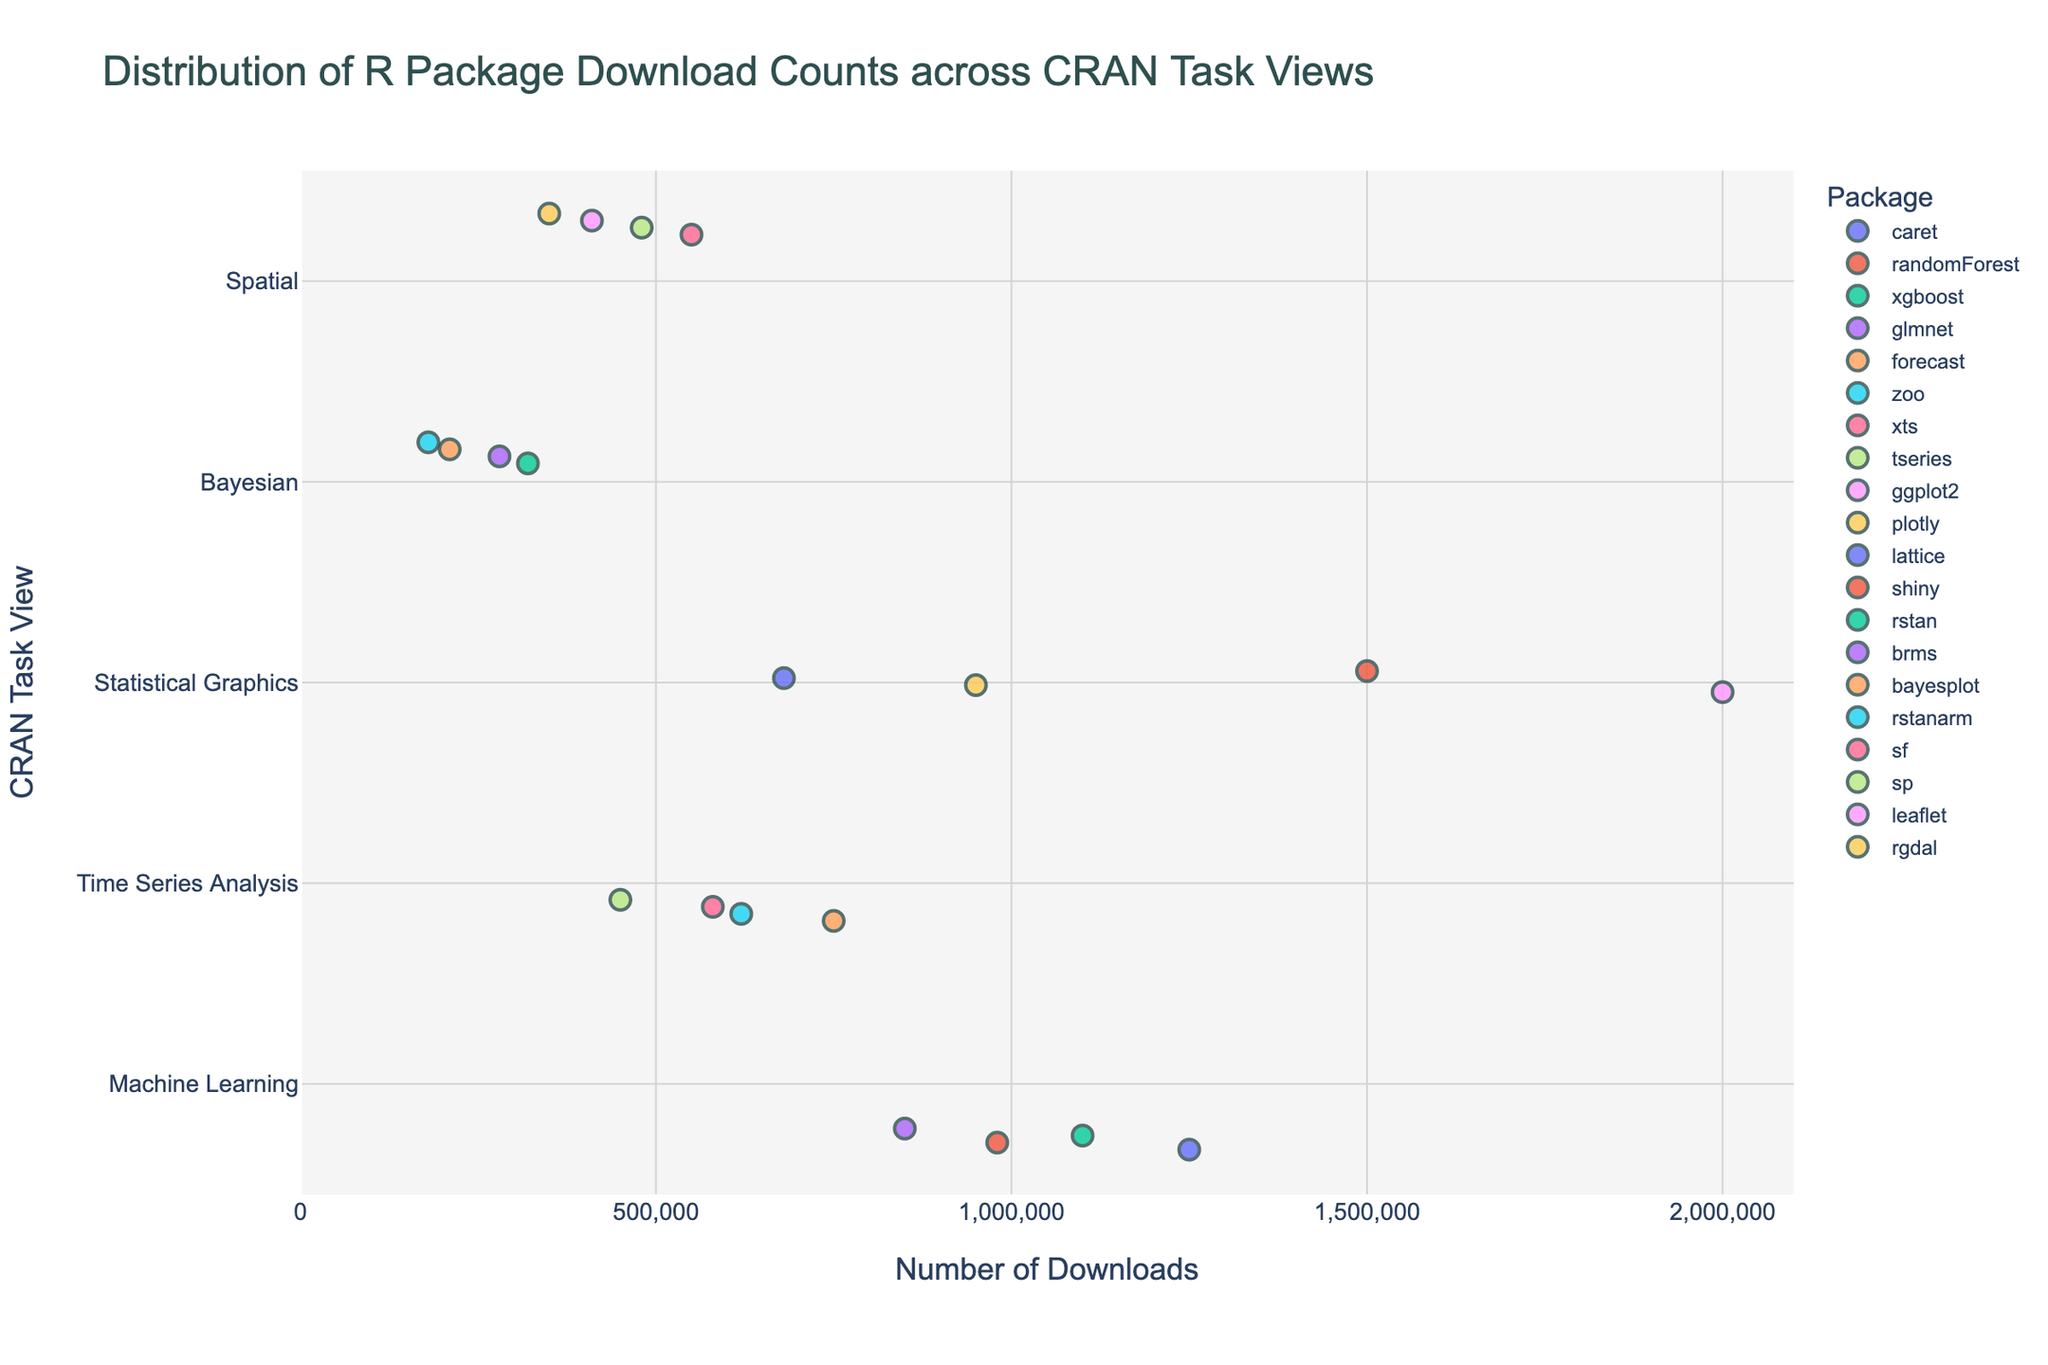What's the title of the plot? The title is typically presented at the top of the plot, it reads "Distribution of R Package Download Counts across CRAN Task Views".
Answer: Distribution of R Package Download Counts across CRAN Task Views Which task view has the highest number of downloads? The highest point on the x-axis that intersects with a task view on the y-axis corresponds to the task view with the highest downloads. "Statistical Graphics" has the highest number of downloads, at 2,000,000 for the 'ggplot2' package.
Answer: Statistical Graphics What is the range of download counts for the "Machine Learning" task view? To find the range, identify the highest and lowest download counts for this task view. The highest count is 1,250,000 for 'caret', and the lowest is 850,000 for 'glmnet'. The range is 1,250,000 - 850,000.
Answer: 400,000 How does the "Bayesian" task view compare to "Time Series Analysis" in terms of package download counts? Compare the points on the x-axis for both task views. "Bayesian" has generally fewer downloads, with the highest for 'rstan' being 320,000, while "Time Series Analysis" has higher counts with 'forecast' reaching 750,000.
Answer: Bayesian has fewer downloads What is the median download count for the "Statistical Graphics" task view? First, list the download counts for this task view: 2,000,000 (ggplot2), 950,000 (plotly), 680,000 (lattice), and 1,500,000 (shiny). Order them: 680,000, 950,000, 1,500,000, 2,000,000. The median is the average of the two middle values: (950,000 + 1,500,000) / 2.
Answer: 1,225,000 Which package has the fewest downloads in the "Spatial" task view? Identify the lowest point on the x-axis that intersects with the "Spatial" label on the y-axis. The package 'rgdal' has the fewest downloads at 350,000.
Answer: rgdal How do the downloads for "xgboost" in "Machine Learning" and "forecast" in "Time Series Analysis" compare? Locate the download counts for these packages. "xgboost" has 1,100,000 downloads whereas "forecast" has 750,000 downloads. Therefore, "xgboost" has more downloads.
Answer: xgboost has more downloads What's the total download count for all packages in the "Bayesian" task view? Sum the download counts for all packages in "Bayesian": 320,000 (rstan) + 280,000 (brms) + 210,000 (bayesplot) + 180,000 (rstanarm). The total is 990,000.
Answer: 990,000 What is the difference in download counts between 'shiny' and 'ggplot2' in the "Statistical Graphics" task view? Identify the download counts for these packages: 'shiny' has 1,500,000 downloads and 'ggplot2' has 2,000,000 downloads. The difference is 2,000,000 - 1,500,000.
Answer: 500,000 